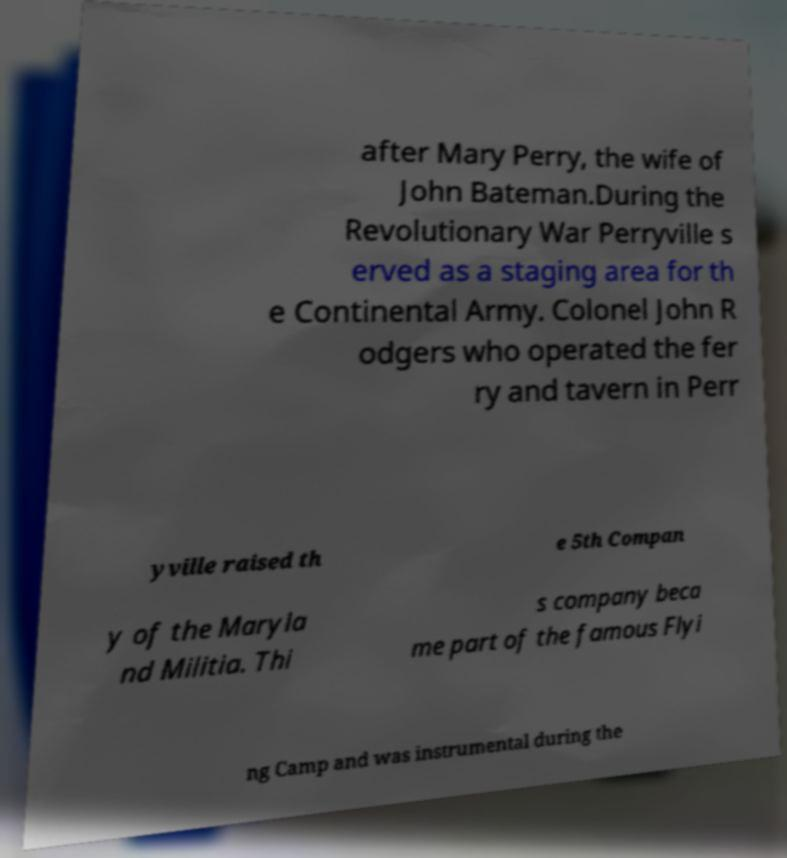What messages or text are displayed in this image? I need them in a readable, typed format. after Mary Perry, the wife of John Bateman.During the Revolutionary War Perryville s erved as a staging area for th e Continental Army. Colonel John R odgers who operated the fer ry and tavern in Perr yville raised th e 5th Compan y of the Maryla nd Militia. Thi s company beca me part of the famous Flyi ng Camp and was instrumental during the 